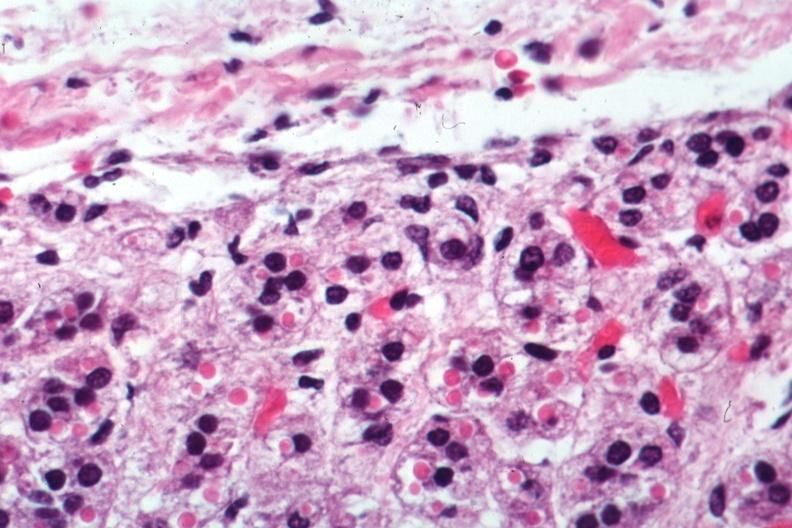s aldactone bodies present?
Answer the question using a single word or phrase. Yes 